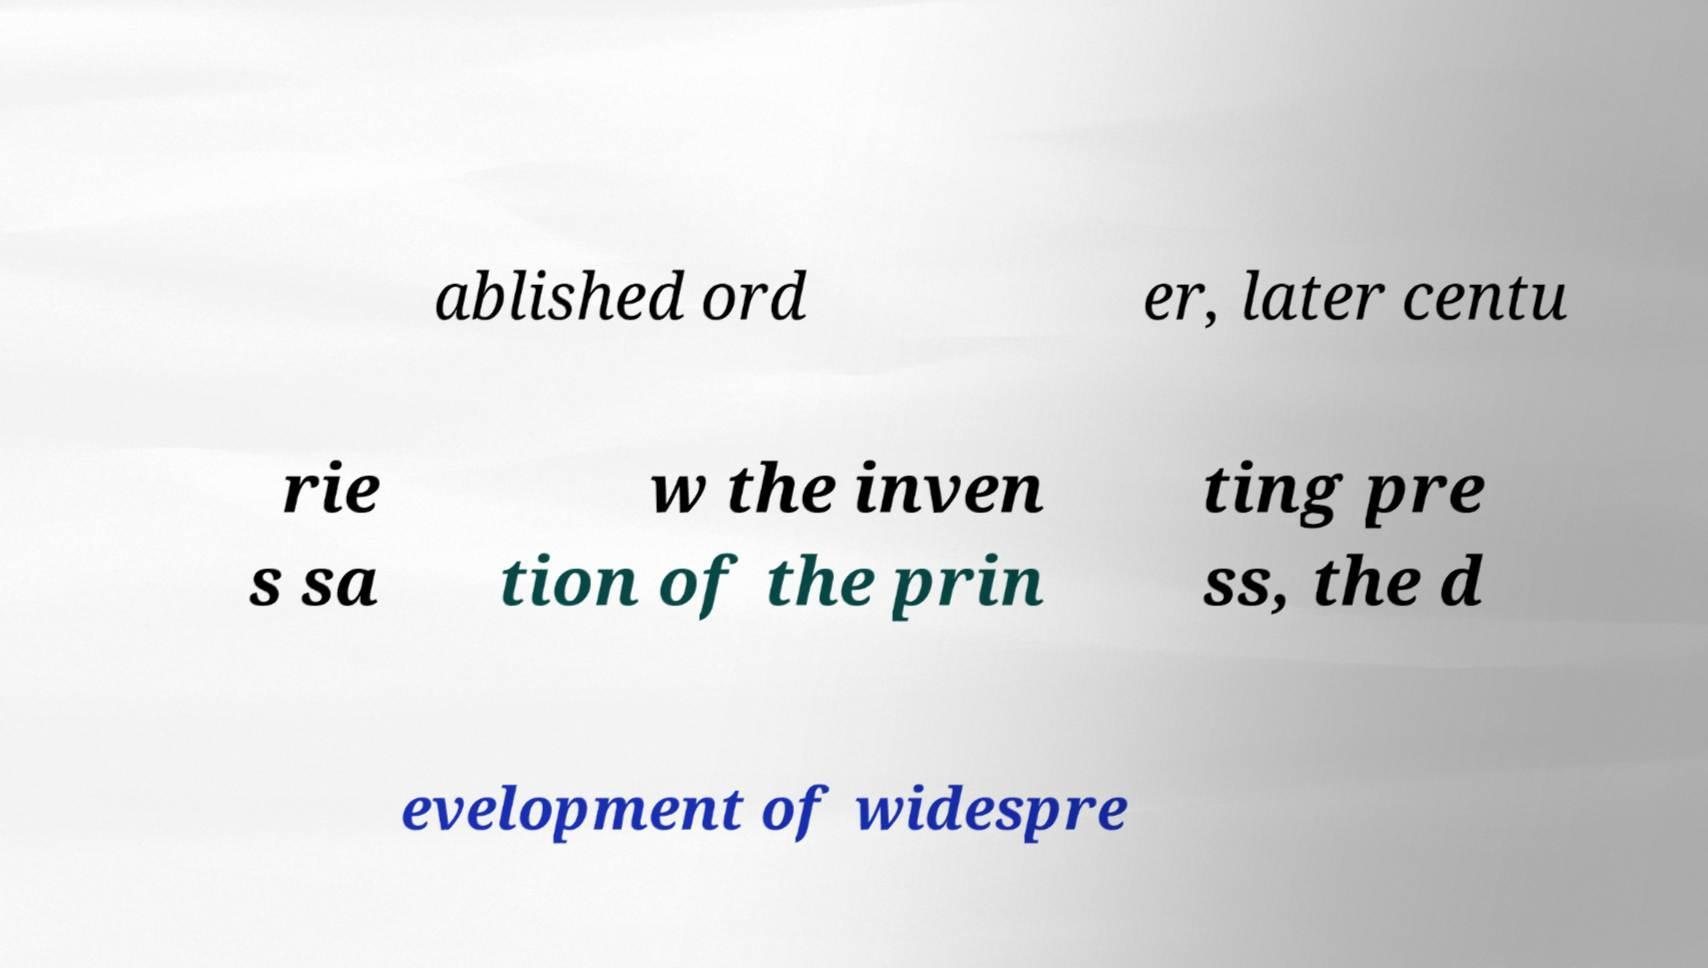Can you accurately transcribe the text from the provided image for me? ablished ord er, later centu rie s sa w the inven tion of the prin ting pre ss, the d evelopment of widespre 